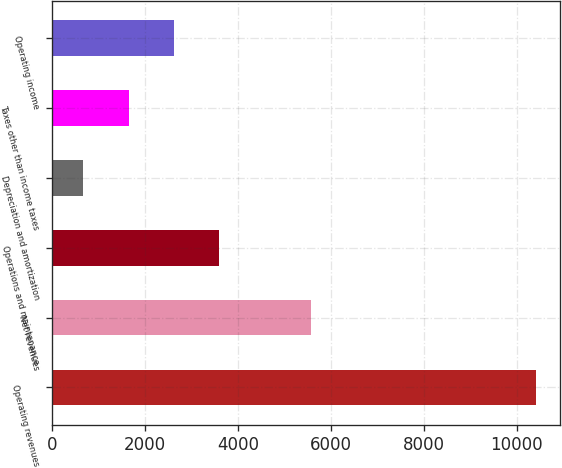<chart> <loc_0><loc_0><loc_500><loc_500><bar_chart><fcel>Operating revenues<fcel>Net revenues<fcel>Operations and maintenance<fcel>Depreciation and amortization<fcel>Taxes other than income taxes<fcel>Operating income<nl><fcel>10424<fcel>5580<fcel>3597.6<fcel>672<fcel>1647.2<fcel>2622.4<nl></chart> 